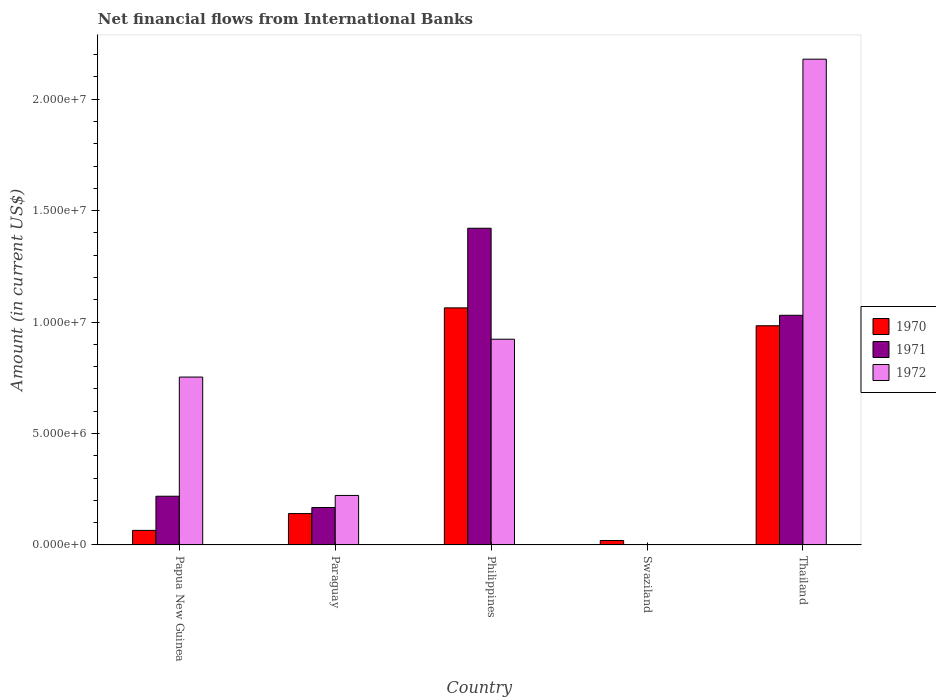How many different coloured bars are there?
Provide a succinct answer. 3. What is the label of the 5th group of bars from the left?
Ensure brevity in your answer.  Thailand. In how many cases, is the number of bars for a given country not equal to the number of legend labels?
Make the answer very short. 1. Across all countries, what is the maximum net financial aid flows in 1970?
Your answer should be compact. 1.06e+07. Across all countries, what is the minimum net financial aid flows in 1972?
Provide a short and direct response. 0. What is the total net financial aid flows in 1970 in the graph?
Ensure brevity in your answer.  2.27e+07. What is the difference between the net financial aid flows in 1972 in Paraguay and that in Philippines?
Offer a terse response. -7.01e+06. What is the difference between the net financial aid flows in 1971 in Paraguay and the net financial aid flows in 1970 in Thailand?
Your response must be concise. -8.15e+06. What is the average net financial aid flows in 1972 per country?
Your answer should be very brief. 8.16e+06. What is the difference between the net financial aid flows of/in 1972 and net financial aid flows of/in 1970 in Paraguay?
Provide a short and direct response. 8.14e+05. In how many countries, is the net financial aid flows in 1971 greater than 19000000 US$?
Your response must be concise. 0. What is the ratio of the net financial aid flows in 1970 in Papua New Guinea to that in Swaziland?
Provide a short and direct response. 3.28. What is the difference between the highest and the second highest net financial aid flows in 1970?
Provide a succinct answer. 8.03e+05. What is the difference between the highest and the lowest net financial aid flows in 1970?
Make the answer very short. 1.04e+07. Is the sum of the net financial aid flows in 1970 in Paraguay and Philippines greater than the maximum net financial aid flows in 1972 across all countries?
Give a very brief answer. No. Is it the case that in every country, the sum of the net financial aid flows in 1971 and net financial aid flows in 1972 is greater than the net financial aid flows in 1970?
Offer a very short reply. No. Are all the bars in the graph horizontal?
Provide a succinct answer. No. How many countries are there in the graph?
Ensure brevity in your answer.  5. What is the difference between two consecutive major ticks on the Y-axis?
Provide a short and direct response. 5.00e+06. Does the graph contain any zero values?
Give a very brief answer. Yes. Where does the legend appear in the graph?
Your answer should be very brief. Center right. How many legend labels are there?
Give a very brief answer. 3. What is the title of the graph?
Give a very brief answer. Net financial flows from International Banks. Does "1999" appear as one of the legend labels in the graph?
Ensure brevity in your answer.  No. What is the label or title of the X-axis?
Your answer should be very brief. Country. What is the label or title of the Y-axis?
Give a very brief answer. Amount (in current US$). What is the Amount (in current US$) of 1970 in Papua New Guinea?
Keep it short and to the point. 6.53e+05. What is the Amount (in current US$) in 1971 in Papua New Guinea?
Give a very brief answer. 2.18e+06. What is the Amount (in current US$) in 1972 in Papua New Guinea?
Provide a short and direct response. 7.53e+06. What is the Amount (in current US$) of 1970 in Paraguay?
Ensure brevity in your answer.  1.41e+06. What is the Amount (in current US$) in 1971 in Paraguay?
Offer a terse response. 1.68e+06. What is the Amount (in current US$) of 1972 in Paraguay?
Keep it short and to the point. 2.22e+06. What is the Amount (in current US$) of 1970 in Philippines?
Keep it short and to the point. 1.06e+07. What is the Amount (in current US$) of 1971 in Philippines?
Offer a terse response. 1.42e+07. What is the Amount (in current US$) of 1972 in Philippines?
Provide a succinct answer. 9.23e+06. What is the Amount (in current US$) in 1970 in Swaziland?
Give a very brief answer. 1.99e+05. What is the Amount (in current US$) of 1971 in Swaziland?
Offer a terse response. 0. What is the Amount (in current US$) of 1970 in Thailand?
Give a very brief answer. 9.83e+06. What is the Amount (in current US$) of 1971 in Thailand?
Your response must be concise. 1.03e+07. What is the Amount (in current US$) of 1972 in Thailand?
Ensure brevity in your answer.  2.18e+07. Across all countries, what is the maximum Amount (in current US$) in 1970?
Keep it short and to the point. 1.06e+07. Across all countries, what is the maximum Amount (in current US$) of 1971?
Give a very brief answer. 1.42e+07. Across all countries, what is the maximum Amount (in current US$) of 1972?
Your response must be concise. 2.18e+07. Across all countries, what is the minimum Amount (in current US$) of 1970?
Make the answer very short. 1.99e+05. Across all countries, what is the minimum Amount (in current US$) of 1971?
Offer a terse response. 0. What is the total Amount (in current US$) in 1970 in the graph?
Make the answer very short. 2.27e+07. What is the total Amount (in current US$) of 1971 in the graph?
Provide a short and direct response. 2.84e+07. What is the total Amount (in current US$) of 1972 in the graph?
Your answer should be compact. 4.08e+07. What is the difference between the Amount (in current US$) of 1970 in Papua New Guinea and that in Paraguay?
Make the answer very short. -7.53e+05. What is the difference between the Amount (in current US$) in 1971 in Papua New Guinea and that in Paraguay?
Offer a terse response. 5.06e+05. What is the difference between the Amount (in current US$) in 1972 in Papua New Guinea and that in Paraguay?
Keep it short and to the point. 5.31e+06. What is the difference between the Amount (in current US$) in 1970 in Papua New Guinea and that in Philippines?
Offer a very short reply. -9.98e+06. What is the difference between the Amount (in current US$) in 1971 in Papua New Guinea and that in Philippines?
Your answer should be very brief. -1.20e+07. What is the difference between the Amount (in current US$) in 1972 in Papua New Guinea and that in Philippines?
Your answer should be very brief. -1.70e+06. What is the difference between the Amount (in current US$) of 1970 in Papua New Guinea and that in Swaziland?
Offer a very short reply. 4.54e+05. What is the difference between the Amount (in current US$) in 1970 in Papua New Guinea and that in Thailand?
Your response must be concise. -9.18e+06. What is the difference between the Amount (in current US$) in 1971 in Papua New Guinea and that in Thailand?
Ensure brevity in your answer.  -8.12e+06. What is the difference between the Amount (in current US$) in 1972 in Papua New Guinea and that in Thailand?
Provide a succinct answer. -1.43e+07. What is the difference between the Amount (in current US$) of 1970 in Paraguay and that in Philippines?
Provide a succinct answer. -9.23e+06. What is the difference between the Amount (in current US$) of 1971 in Paraguay and that in Philippines?
Keep it short and to the point. -1.25e+07. What is the difference between the Amount (in current US$) of 1972 in Paraguay and that in Philippines?
Your answer should be very brief. -7.01e+06. What is the difference between the Amount (in current US$) of 1970 in Paraguay and that in Swaziland?
Your answer should be very brief. 1.21e+06. What is the difference between the Amount (in current US$) of 1970 in Paraguay and that in Thailand?
Ensure brevity in your answer.  -8.43e+06. What is the difference between the Amount (in current US$) of 1971 in Paraguay and that in Thailand?
Your response must be concise. -8.62e+06. What is the difference between the Amount (in current US$) of 1972 in Paraguay and that in Thailand?
Offer a terse response. -1.96e+07. What is the difference between the Amount (in current US$) of 1970 in Philippines and that in Swaziland?
Make the answer very short. 1.04e+07. What is the difference between the Amount (in current US$) in 1970 in Philippines and that in Thailand?
Your response must be concise. 8.03e+05. What is the difference between the Amount (in current US$) in 1971 in Philippines and that in Thailand?
Offer a very short reply. 3.90e+06. What is the difference between the Amount (in current US$) of 1972 in Philippines and that in Thailand?
Provide a short and direct response. -1.26e+07. What is the difference between the Amount (in current US$) of 1970 in Swaziland and that in Thailand?
Provide a succinct answer. -9.63e+06. What is the difference between the Amount (in current US$) of 1970 in Papua New Guinea and the Amount (in current US$) of 1971 in Paraguay?
Offer a terse response. -1.03e+06. What is the difference between the Amount (in current US$) of 1970 in Papua New Guinea and the Amount (in current US$) of 1972 in Paraguay?
Your response must be concise. -1.57e+06. What is the difference between the Amount (in current US$) of 1971 in Papua New Guinea and the Amount (in current US$) of 1972 in Paraguay?
Give a very brief answer. -3.50e+04. What is the difference between the Amount (in current US$) of 1970 in Papua New Guinea and the Amount (in current US$) of 1971 in Philippines?
Offer a very short reply. -1.36e+07. What is the difference between the Amount (in current US$) in 1970 in Papua New Guinea and the Amount (in current US$) in 1972 in Philippines?
Your answer should be compact. -8.58e+06. What is the difference between the Amount (in current US$) in 1971 in Papua New Guinea and the Amount (in current US$) in 1972 in Philippines?
Offer a very short reply. -7.04e+06. What is the difference between the Amount (in current US$) in 1970 in Papua New Guinea and the Amount (in current US$) in 1971 in Thailand?
Offer a terse response. -9.65e+06. What is the difference between the Amount (in current US$) of 1970 in Papua New Guinea and the Amount (in current US$) of 1972 in Thailand?
Give a very brief answer. -2.11e+07. What is the difference between the Amount (in current US$) of 1971 in Papua New Guinea and the Amount (in current US$) of 1972 in Thailand?
Your answer should be very brief. -1.96e+07. What is the difference between the Amount (in current US$) of 1970 in Paraguay and the Amount (in current US$) of 1971 in Philippines?
Make the answer very short. -1.28e+07. What is the difference between the Amount (in current US$) in 1970 in Paraguay and the Amount (in current US$) in 1972 in Philippines?
Offer a very short reply. -7.82e+06. What is the difference between the Amount (in current US$) in 1971 in Paraguay and the Amount (in current US$) in 1972 in Philippines?
Your response must be concise. -7.55e+06. What is the difference between the Amount (in current US$) of 1970 in Paraguay and the Amount (in current US$) of 1971 in Thailand?
Provide a short and direct response. -8.90e+06. What is the difference between the Amount (in current US$) of 1970 in Paraguay and the Amount (in current US$) of 1972 in Thailand?
Keep it short and to the point. -2.04e+07. What is the difference between the Amount (in current US$) of 1971 in Paraguay and the Amount (in current US$) of 1972 in Thailand?
Your answer should be very brief. -2.01e+07. What is the difference between the Amount (in current US$) in 1970 in Philippines and the Amount (in current US$) in 1971 in Thailand?
Provide a succinct answer. 3.33e+05. What is the difference between the Amount (in current US$) of 1970 in Philippines and the Amount (in current US$) of 1972 in Thailand?
Keep it short and to the point. -1.12e+07. What is the difference between the Amount (in current US$) in 1971 in Philippines and the Amount (in current US$) in 1972 in Thailand?
Your answer should be compact. -7.59e+06. What is the difference between the Amount (in current US$) of 1970 in Swaziland and the Amount (in current US$) of 1971 in Thailand?
Ensure brevity in your answer.  -1.01e+07. What is the difference between the Amount (in current US$) in 1970 in Swaziland and the Amount (in current US$) in 1972 in Thailand?
Offer a terse response. -2.16e+07. What is the average Amount (in current US$) in 1970 per country?
Keep it short and to the point. 4.55e+06. What is the average Amount (in current US$) of 1971 per country?
Your answer should be compact. 5.68e+06. What is the average Amount (in current US$) of 1972 per country?
Provide a succinct answer. 8.16e+06. What is the difference between the Amount (in current US$) in 1970 and Amount (in current US$) in 1971 in Papua New Guinea?
Make the answer very short. -1.53e+06. What is the difference between the Amount (in current US$) of 1970 and Amount (in current US$) of 1972 in Papua New Guinea?
Offer a terse response. -6.88e+06. What is the difference between the Amount (in current US$) in 1971 and Amount (in current US$) in 1972 in Papua New Guinea?
Keep it short and to the point. -5.35e+06. What is the difference between the Amount (in current US$) of 1970 and Amount (in current US$) of 1971 in Paraguay?
Make the answer very short. -2.73e+05. What is the difference between the Amount (in current US$) in 1970 and Amount (in current US$) in 1972 in Paraguay?
Give a very brief answer. -8.14e+05. What is the difference between the Amount (in current US$) of 1971 and Amount (in current US$) of 1972 in Paraguay?
Provide a short and direct response. -5.41e+05. What is the difference between the Amount (in current US$) of 1970 and Amount (in current US$) of 1971 in Philippines?
Your answer should be very brief. -3.57e+06. What is the difference between the Amount (in current US$) of 1970 and Amount (in current US$) of 1972 in Philippines?
Ensure brevity in your answer.  1.41e+06. What is the difference between the Amount (in current US$) in 1971 and Amount (in current US$) in 1972 in Philippines?
Offer a very short reply. 4.98e+06. What is the difference between the Amount (in current US$) in 1970 and Amount (in current US$) in 1971 in Thailand?
Make the answer very short. -4.70e+05. What is the difference between the Amount (in current US$) in 1970 and Amount (in current US$) in 1972 in Thailand?
Ensure brevity in your answer.  -1.20e+07. What is the difference between the Amount (in current US$) in 1971 and Amount (in current US$) in 1972 in Thailand?
Make the answer very short. -1.15e+07. What is the ratio of the Amount (in current US$) of 1970 in Papua New Guinea to that in Paraguay?
Make the answer very short. 0.46. What is the ratio of the Amount (in current US$) of 1971 in Papua New Guinea to that in Paraguay?
Make the answer very short. 1.3. What is the ratio of the Amount (in current US$) in 1972 in Papua New Guinea to that in Paraguay?
Your response must be concise. 3.39. What is the ratio of the Amount (in current US$) in 1970 in Papua New Guinea to that in Philippines?
Keep it short and to the point. 0.06. What is the ratio of the Amount (in current US$) in 1971 in Papua New Guinea to that in Philippines?
Your answer should be compact. 0.15. What is the ratio of the Amount (in current US$) of 1972 in Papua New Guinea to that in Philippines?
Your response must be concise. 0.82. What is the ratio of the Amount (in current US$) of 1970 in Papua New Guinea to that in Swaziland?
Provide a succinct answer. 3.28. What is the ratio of the Amount (in current US$) of 1970 in Papua New Guinea to that in Thailand?
Give a very brief answer. 0.07. What is the ratio of the Amount (in current US$) of 1971 in Papua New Guinea to that in Thailand?
Your answer should be very brief. 0.21. What is the ratio of the Amount (in current US$) in 1972 in Papua New Guinea to that in Thailand?
Provide a succinct answer. 0.35. What is the ratio of the Amount (in current US$) of 1970 in Paraguay to that in Philippines?
Provide a short and direct response. 0.13. What is the ratio of the Amount (in current US$) in 1971 in Paraguay to that in Philippines?
Your answer should be compact. 0.12. What is the ratio of the Amount (in current US$) of 1972 in Paraguay to that in Philippines?
Offer a terse response. 0.24. What is the ratio of the Amount (in current US$) of 1970 in Paraguay to that in Swaziland?
Ensure brevity in your answer.  7.07. What is the ratio of the Amount (in current US$) of 1970 in Paraguay to that in Thailand?
Your response must be concise. 0.14. What is the ratio of the Amount (in current US$) in 1971 in Paraguay to that in Thailand?
Offer a very short reply. 0.16. What is the ratio of the Amount (in current US$) in 1972 in Paraguay to that in Thailand?
Ensure brevity in your answer.  0.1. What is the ratio of the Amount (in current US$) of 1970 in Philippines to that in Swaziland?
Your response must be concise. 53.45. What is the ratio of the Amount (in current US$) of 1970 in Philippines to that in Thailand?
Provide a short and direct response. 1.08. What is the ratio of the Amount (in current US$) in 1971 in Philippines to that in Thailand?
Provide a short and direct response. 1.38. What is the ratio of the Amount (in current US$) in 1972 in Philippines to that in Thailand?
Ensure brevity in your answer.  0.42. What is the ratio of the Amount (in current US$) of 1970 in Swaziland to that in Thailand?
Provide a succinct answer. 0.02. What is the difference between the highest and the second highest Amount (in current US$) in 1970?
Provide a succinct answer. 8.03e+05. What is the difference between the highest and the second highest Amount (in current US$) in 1971?
Make the answer very short. 3.90e+06. What is the difference between the highest and the second highest Amount (in current US$) in 1972?
Give a very brief answer. 1.26e+07. What is the difference between the highest and the lowest Amount (in current US$) in 1970?
Your response must be concise. 1.04e+07. What is the difference between the highest and the lowest Amount (in current US$) in 1971?
Your answer should be very brief. 1.42e+07. What is the difference between the highest and the lowest Amount (in current US$) in 1972?
Offer a very short reply. 2.18e+07. 